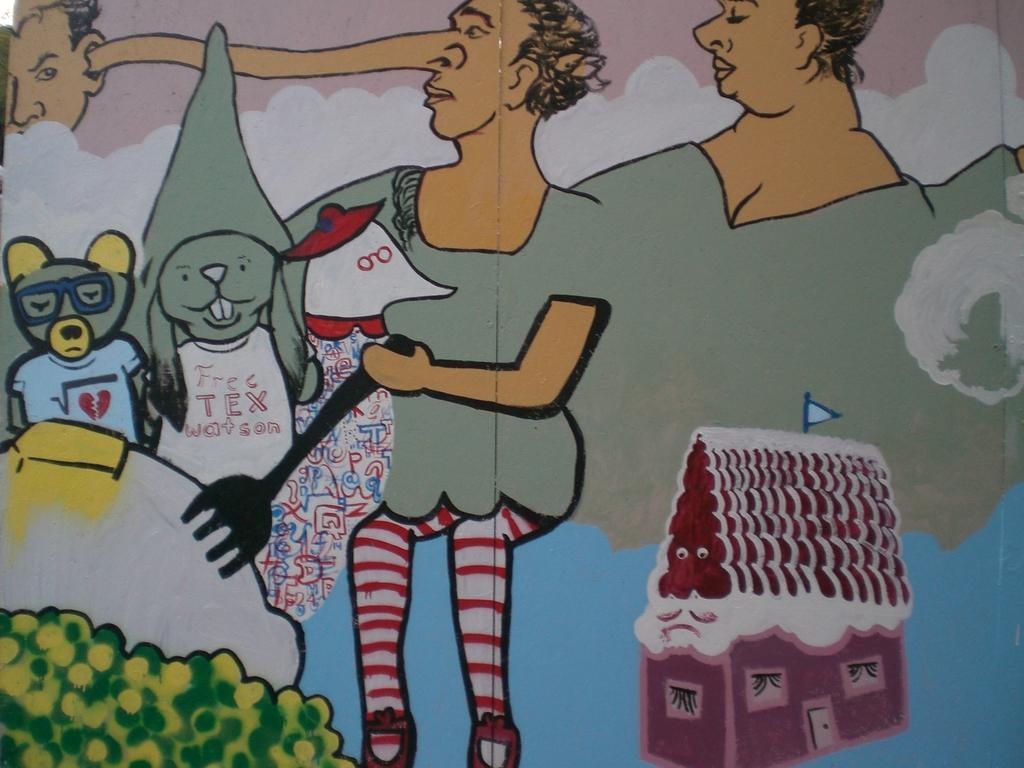What is the main subject in the center of the image? There is a poster in the center of the image. What types of creatures are depicted on the poster? The poster contains animals. What else can be seen on the poster besides animals? The poster contains people sitting in series. Are there any objects or structures on the poster? Yes, there is a toy house on the poster. What type of haircut can be seen on the bushes in the image? There are no bushes or haircuts present in the image; it features a poster with animals, people, and a toy house. 